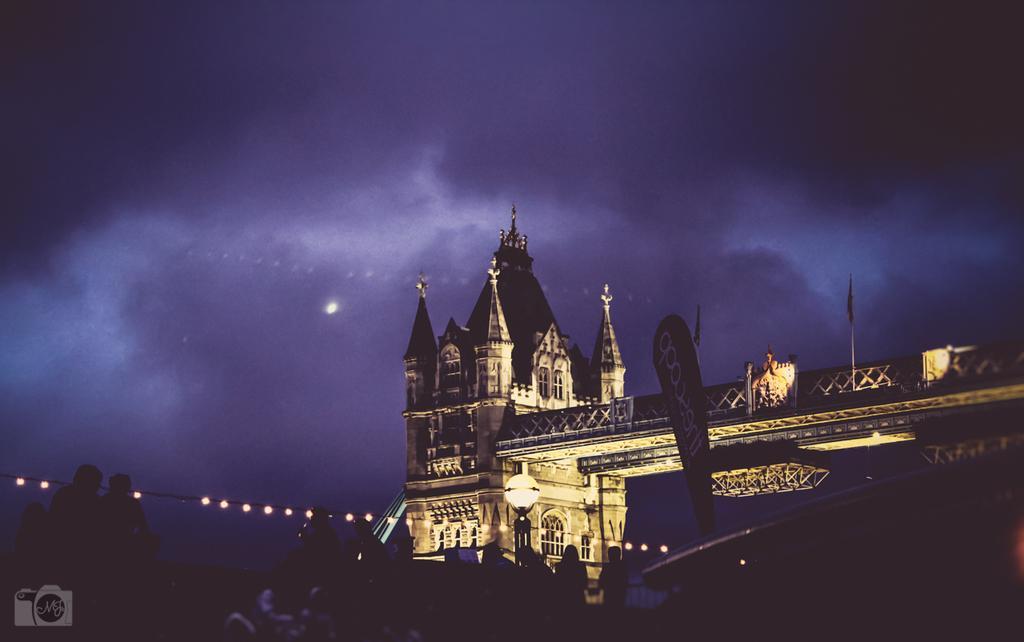How would you summarize this image in a sentence or two? In the foreground of this image, there are people, building, lights and a banner flag like an object. At the top, there is the dark sky. 